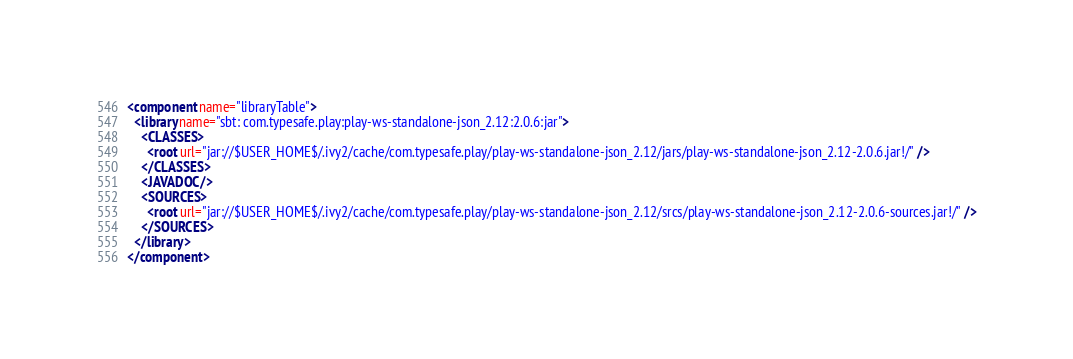Convert code to text. <code><loc_0><loc_0><loc_500><loc_500><_XML_><component name="libraryTable">
  <library name="sbt: com.typesafe.play:play-ws-standalone-json_2.12:2.0.6:jar">
    <CLASSES>
      <root url="jar://$USER_HOME$/.ivy2/cache/com.typesafe.play/play-ws-standalone-json_2.12/jars/play-ws-standalone-json_2.12-2.0.6.jar!/" />
    </CLASSES>
    <JAVADOC />
    <SOURCES>
      <root url="jar://$USER_HOME$/.ivy2/cache/com.typesafe.play/play-ws-standalone-json_2.12/srcs/play-ws-standalone-json_2.12-2.0.6-sources.jar!/" />
    </SOURCES>
  </library>
</component></code> 